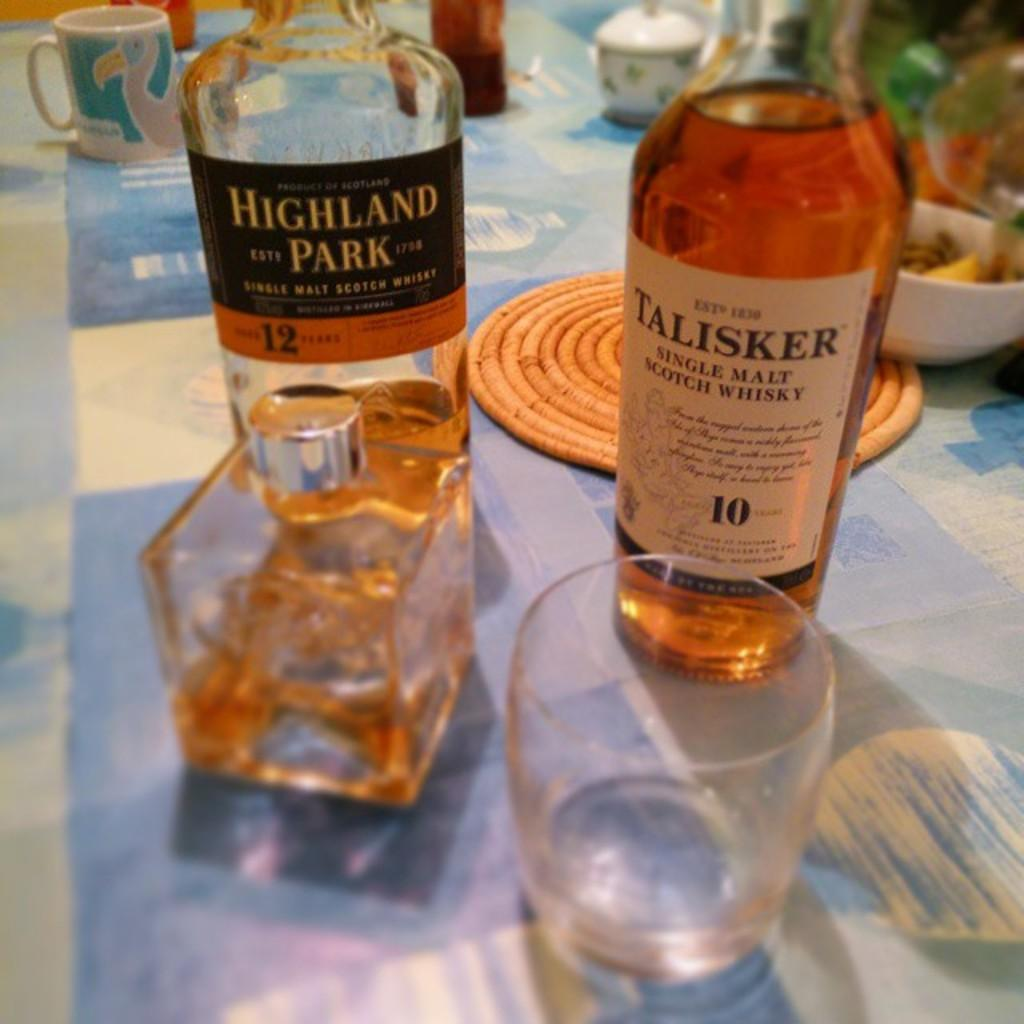<image>
Write a terse but informative summary of the picture. Bottles of Highland Park Single Malt Scotch Whisky and Talisker Single Malt Scotch Whisky are placed on a kitchen table. 